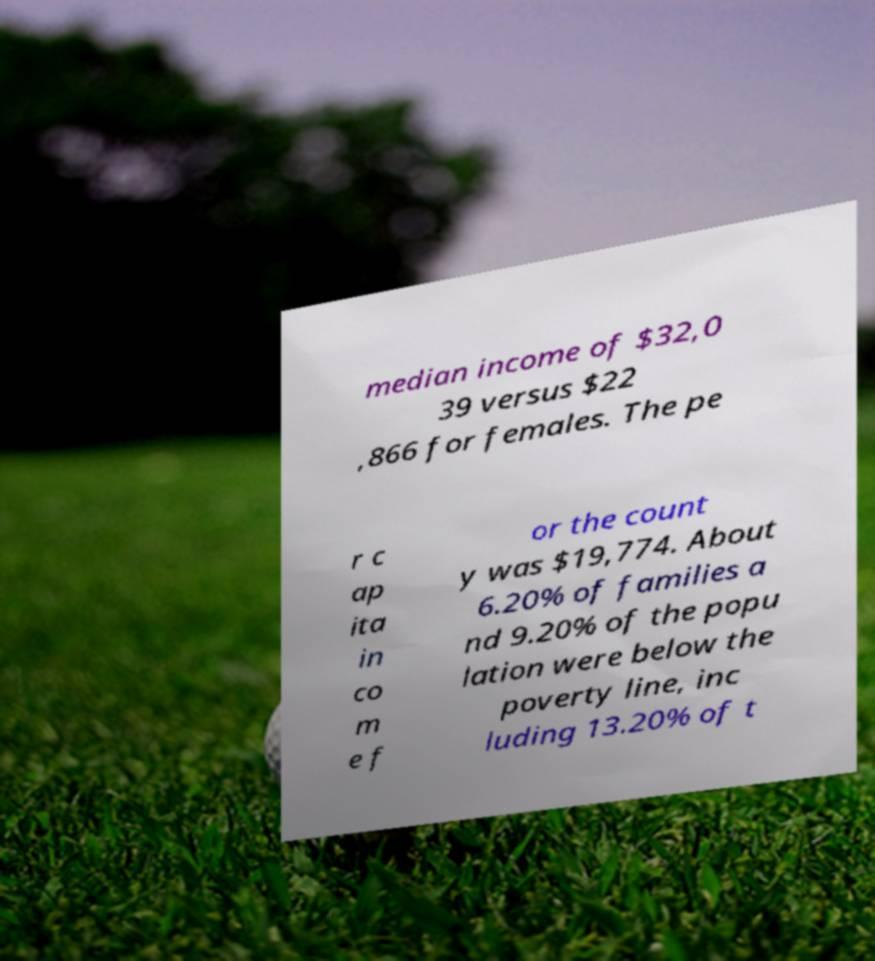Please identify and transcribe the text found in this image. median income of $32,0 39 versus $22 ,866 for females. The pe r c ap ita in co m e f or the count y was $19,774. About 6.20% of families a nd 9.20% of the popu lation were below the poverty line, inc luding 13.20% of t 